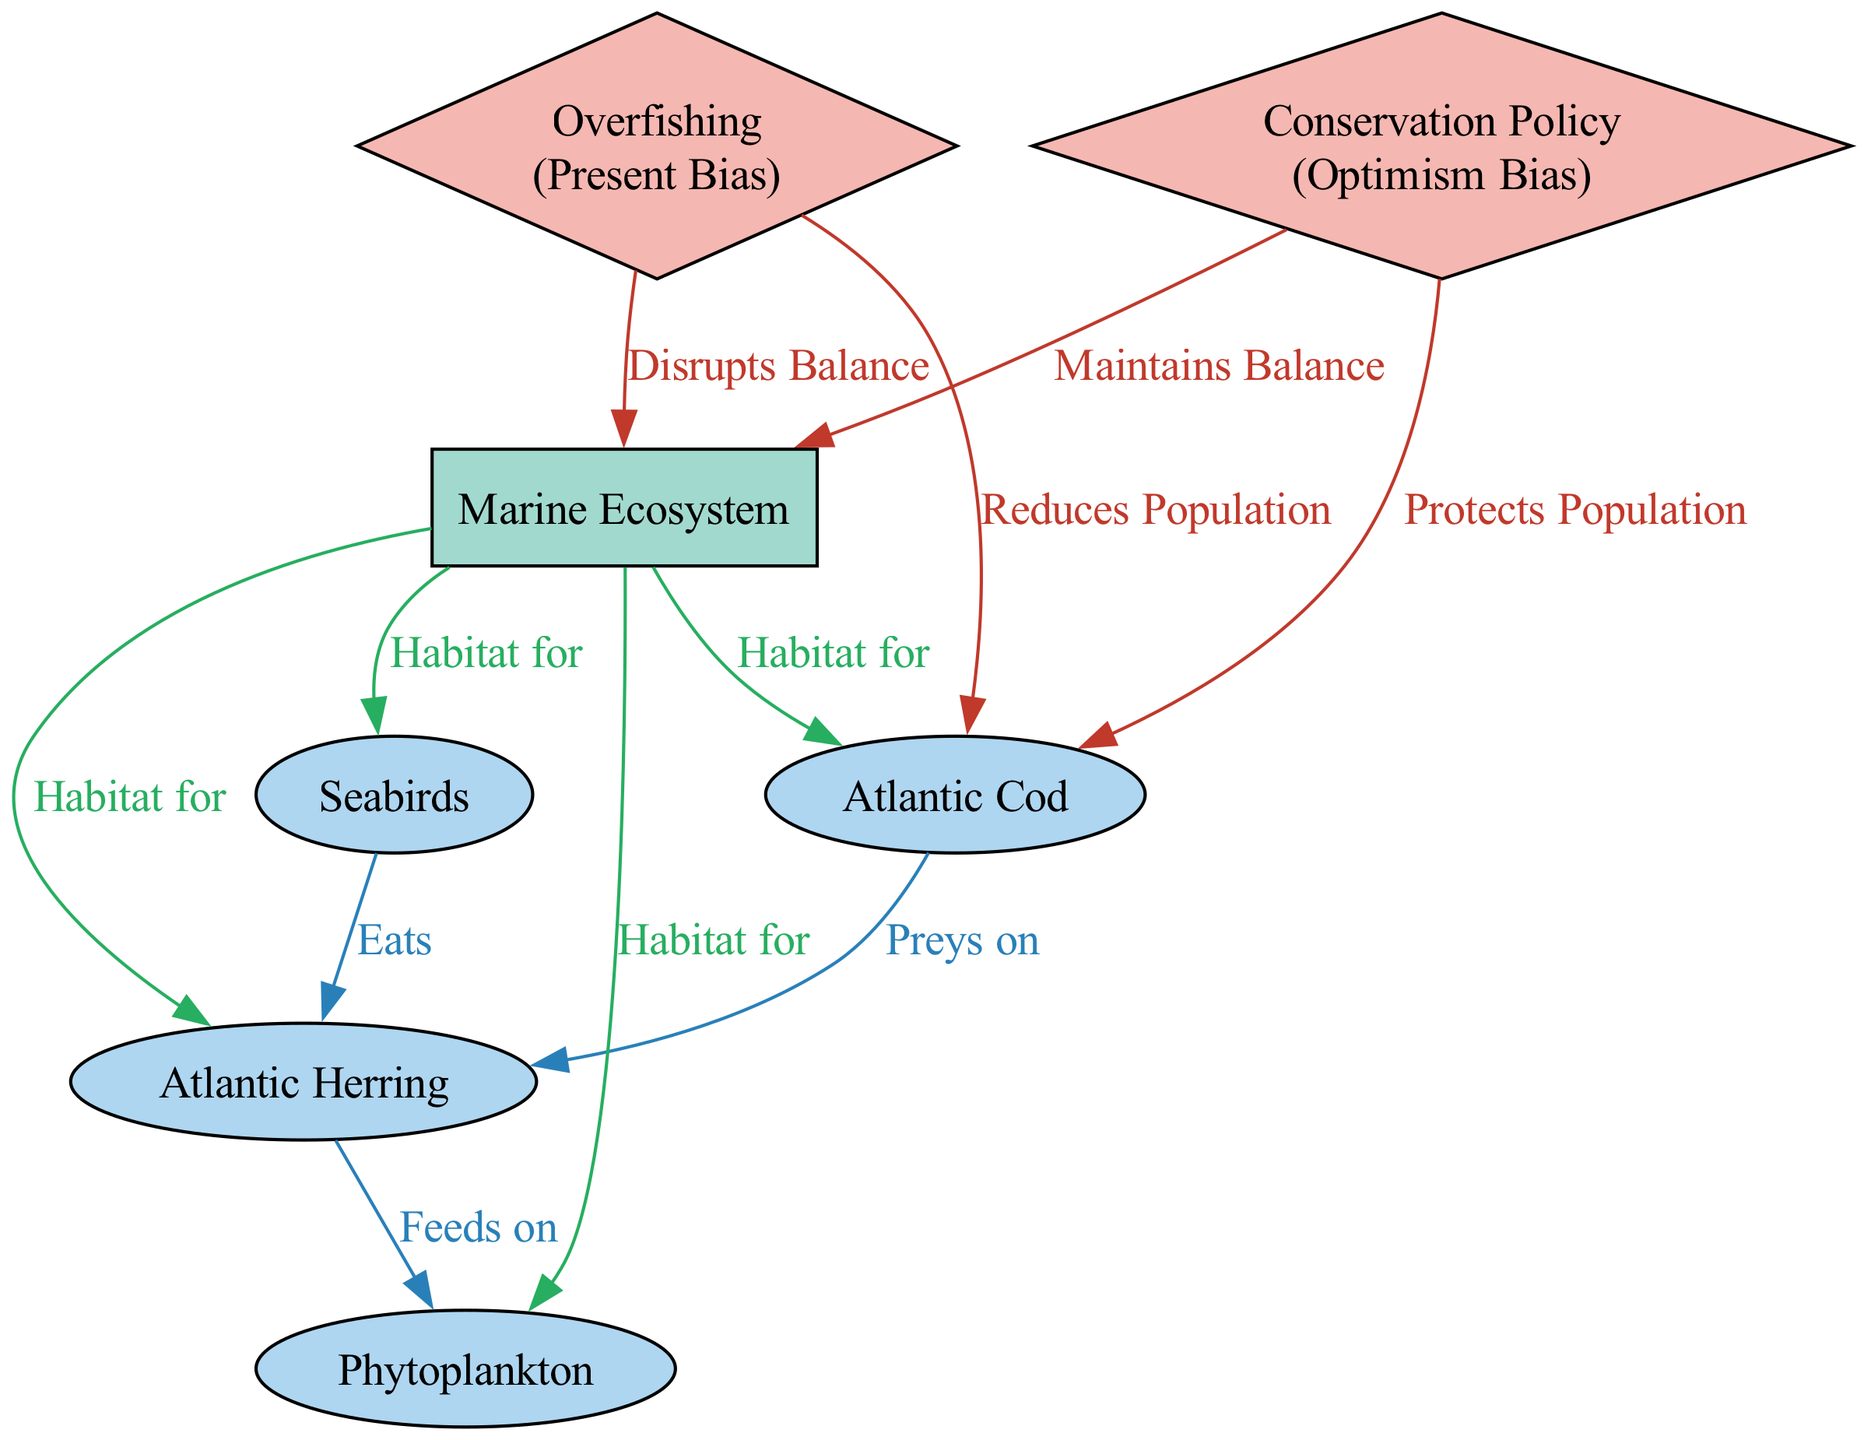What species preys on the Atlantic Herring? The diagram shows a directed edge labeled "Preys on" from the Atlantic Cod to the Atlantic Herring. This indicates a predator-prey relationship where the Atlantic Cod is the predator that preys on the Atlantic Herring.
Answer: Atlantic Cod Which species are present in the Marine Ecosystem? The diagram indicates containment relationships where multiple nodes represent species that have connections with the Marine Ecosystem. Specifically, the Atlantic Cod, Atlantic Herring, Seabirds, and Phytoplankton are all labeled as "Habitat for" in their relationship with the Marine Ecosystem.
Answer: Atlantic Cod, Atlantic Herring, Seabirds, Phytoplankton What is the impact of Overfishing on the population of Atlantic Cod? According to the diagram, there is an edge labeled "Reduces Population" that leads from the decision Overfishing to the species Atlantic Cod, meaning that Overfishing has a negative impact on the population of this species.
Answer: Reduces Population How many edges are connected to the Atlantic Herring? To determine the number of edges connected to the Atlantic Herring, we refer to the diagram and count the interactions and impacts. The Atlantic Herring has two edges directed towards it: one from Atlantic Cod (Eats) and one from Atlantic Herring to Phytoplankton (Feeds on), resulting in a total of two edges.
Answer: 2 What decision is associated with maintaining balance in the Marine Ecosystem? The diagram highlights a decision labeled "Conservation Policy" that is connected to the Marine Ecosystem. An edge marked "Maintains Balance" indicates that this decision promotes ecological stability within the Marine Ecosystem.
Answer: Conservation Policy How does Overfishing influence the Marine Ecosystem? The diagram depicts a directed edge from the decision Overfishing to the Marine Ecosystem, labeled "Disrupts Balance." This explicitly shows that Overfishing negatively affects the ecological balance within the Marine Ecosystem.
Answer: Disrupts Balance Which cognitive bias is related to the decision of Conservation Policy? The diagram specifies that the decision nodes have corresponding biases associated with them. For the decision labeled Conservation Policy, the bias indicated is "Optimism Bias," suggesting an overly positive outlook when making conservation strategies.
Answer: Optimism Bias What type of interaction exists between Seabirds and Atlantic Herring? The relationship between Seabirds and Atlantic Herring is characterized by an edge labeled "Eats," indicating that Seabirds consume Atlantic Herring. This indicates the nature of the food relationship.
Answer: Eats 